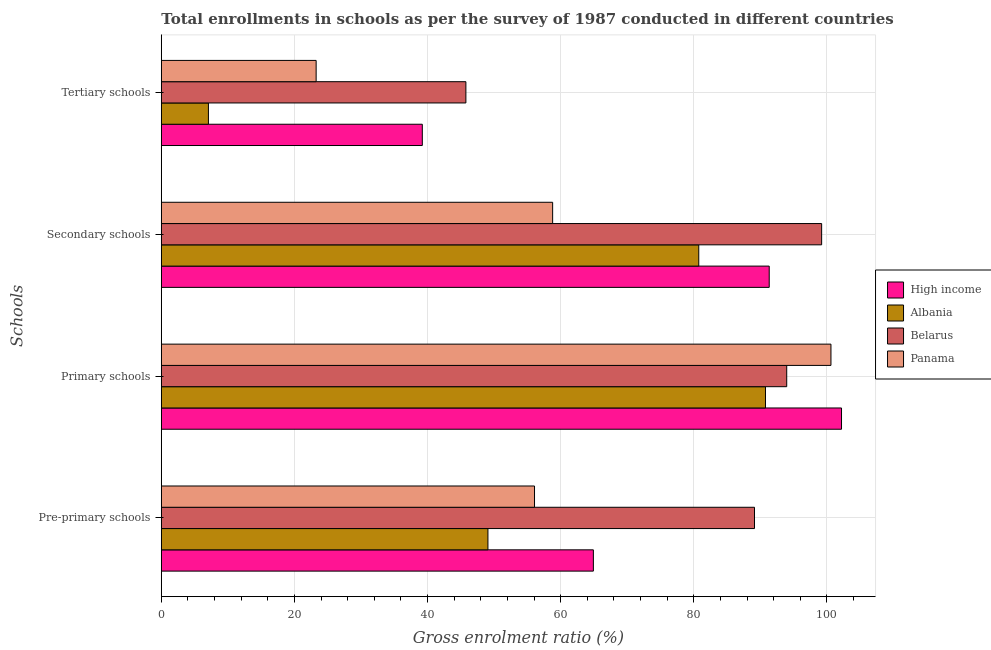How many groups of bars are there?
Offer a very short reply. 4. Are the number of bars per tick equal to the number of legend labels?
Provide a succinct answer. Yes. Are the number of bars on each tick of the Y-axis equal?
Your answer should be very brief. Yes. How many bars are there on the 1st tick from the top?
Offer a very short reply. 4. What is the label of the 1st group of bars from the top?
Keep it short and to the point. Tertiary schools. What is the gross enrolment ratio in pre-primary schools in Belarus?
Provide a succinct answer. 89.12. Across all countries, what is the maximum gross enrolment ratio in primary schools?
Offer a very short reply. 102.19. Across all countries, what is the minimum gross enrolment ratio in pre-primary schools?
Your response must be concise. 49.07. In which country was the gross enrolment ratio in pre-primary schools maximum?
Offer a very short reply. Belarus. In which country was the gross enrolment ratio in pre-primary schools minimum?
Provide a succinct answer. Albania. What is the total gross enrolment ratio in primary schools in the graph?
Provide a short and direct response. 387.51. What is the difference between the gross enrolment ratio in tertiary schools in Belarus and that in Albania?
Provide a short and direct response. 38.68. What is the difference between the gross enrolment ratio in tertiary schools in High income and the gross enrolment ratio in pre-primary schools in Belarus?
Your answer should be compact. -49.91. What is the average gross enrolment ratio in primary schools per country?
Offer a very short reply. 96.88. What is the difference between the gross enrolment ratio in tertiary schools and gross enrolment ratio in secondary schools in Albania?
Provide a succinct answer. -73.67. What is the ratio of the gross enrolment ratio in secondary schools in Panama to that in Belarus?
Your answer should be very brief. 0.59. What is the difference between the highest and the second highest gross enrolment ratio in secondary schools?
Make the answer very short. 7.88. What is the difference between the highest and the lowest gross enrolment ratio in secondary schools?
Offer a very short reply. 40.41. In how many countries, is the gross enrolment ratio in primary schools greater than the average gross enrolment ratio in primary schools taken over all countries?
Offer a terse response. 2. What does the 2nd bar from the top in Tertiary schools represents?
Offer a terse response. Belarus. What does the 4th bar from the bottom in Pre-primary schools represents?
Your response must be concise. Panama. Is it the case that in every country, the sum of the gross enrolment ratio in pre-primary schools and gross enrolment ratio in primary schools is greater than the gross enrolment ratio in secondary schools?
Make the answer very short. Yes. Are all the bars in the graph horizontal?
Your response must be concise. Yes. How many countries are there in the graph?
Your answer should be compact. 4. Are the values on the major ticks of X-axis written in scientific E-notation?
Give a very brief answer. No. Where does the legend appear in the graph?
Give a very brief answer. Center right. How many legend labels are there?
Provide a succinct answer. 4. How are the legend labels stacked?
Give a very brief answer. Vertical. What is the title of the graph?
Offer a terse response. Total enrollments in schools as per the survey of 1987 conducted in different countries. Does "Malaysia" appear as one of the legend labels in the graph?
Your answer should be compact. No. What is the label or title of the Y-axis?
Keep it short and to the point. Schools. What is the Gross enrolment ratio (%) of High income in Pre-primary schools?
Provide a succinct answer. 64.91. What is the Gross enrolment ratio (%) of Albania in Pre-primary schools?
Your answer should be compact. 49.07. What is the Gross enrolment ratio (%) in Belarus in Pre-primary schools?
Ensure brevity in your answer.  89.12. What is the Gross enrolment ratio (%) of Panama in Pre-primary schools?
Your response must be concise. 56.07. What is the Gross enrolment ratio (%) in High income in Primary schools?
Make the answer very short. 102.19. What is the Gross enrolment ratio (%) in Albania in Primary schools?
Give a very brief answer. 90.77. What is the Gross enrolment ratio (%) in Belarus in Primary schools?
Offer a terse response. 93.95. What is the Gross enrolment ratio (%) in Panama in Primary schools?
Make the answer very short. 100.6. What is the Gross enrolment ratio (%) in High income in Secondary schools?
Offer a very short reply. 91.33. What is the Gross enrolment ratio (%) in Albania in Secondary schools?
Provide a succinct answer. 80.74. What is the Gross enrolment ratio (%) of Belarus in Secondary schools?
Ensure brevity in your answer.  99.2. What is the Gross enrolment ratio (%) in Panama in Secondary schools?
Provide a succinct answer. 58.79. What is the Gross enrolment ratio (%) of High income in Tertiary schools?
Offer a very short reply. 39.21. What is the Gross enrolment ratio (%) of Albania in Tertiary schools?
Provide a short and direct response. 7.08. What is the Gross enrolment ratio (%) in Belarus in Tertiary schools?
Your answer should be very brief. 45.76. What is the Gross enrolment ratio (%) in Panama in Tertiary schools?
Make the answer very short. 23.26. Across all Schools, what is the maximum Gross enrolment ratio (%) of High income?
Your response must be concise. 102.19. Across all Schools, what is the maximum Gross enrolment ratio (%) of Albania?
Ensure brevity in your answer.  90.77. Across all Schools, what is the maximum Gross enrolment ratio (%) in Belarus?
Offer a terse response. 99.2. Across all Schools, what is the maximum Gross enrolment ratio (%) in Panama?
Provide a succinct answer. 100.6. Across all Schools, what is the minimum Gross enrolment ratio (%) in High income?
Offer a very short reply. 39.21. Across all Schools, what is the minimum Gross enrolment ratio (%) of Albania?
Offer a very short reply. 7.08. Across all Schools, what is the minimum Gross enrolment ratio (%) of Belarus?
Provide a short and direct response. 45.76. Across all Schools, what is the minimum Gross enrolment ratio (%) of Panama?
Ensure brevity in your answer.  23.26. What is the total Gross enrolment ratio (%) in High income in the graph?
Your answer should be very brief. 297.63. What is the total Gross enrolment ratio (%) in Albania in the graph?
Your answer should be very brief. 227.65. What is the total Gross enrolment ratio (%) in Belarus in the graph?
Your response must be concise. 328.03. What is the total Gross enrolment ratio (%) of Panama in the graph?
Provide a short and direct response. 238.72. What is the difference between the Gross enrolment ratio (%) in High income in Pre-primary schools and that in Primary schools?
Provide a succinct answer. -37.28. What is the difference between the Gross enrolment ratio (%) in Albania in Pre-primary schools and that in Primary schools?
Your response must be concise. -41.7. What is the difference between the Gross enrolment ratio (%) of Belarus in Pre-primary schools and that in Primary schools?
Keep it short and to the point. -4.84. What is the difference between the Gross enrolment ratio (%) of Panama in Pre-primary schools and that in Primary schools?
Provide a short and direct response. -44.54. What is the difference between the Gross enrolment ratio (%) in High income in Pre-primary schools and that in Secondary schools?
Ensure brevity in your answer.  -26.42. What is the difference between the Gross enrolment ratio (%) in Albania in Pre-primary schools and that in Secondary schools?
Make the answer very short. -31.67. What is the difference between the Gross enrolment ratio (%) of Belarus in Pre-primary schools and that in Secondary schools?
Offer a very short reply. -10.09. What is the difference between the Gross enrolment ratio (%) of Panama in Pre-primary schools and that in Secondary schools?
Your answer should be very brief. -2.72. What is the difference between the Gross enrolment ratio (%) of High income in Pre-primary schools and that in Tertiary schools?
Your response must be concise. 25.7. What is the difference between the Gross enrolment ratio (%) in Albania in Pre-primary schools and that in Tertiary schools?
Your response must be concise. 41.99. What is the difference between the Gross enrolment ratio (%) of Belarus in Pre-primary schools and that in Tertiary schools?
Keep it short and to the point. 43.36. What is the difference between the Gross enrolment ratio (%) in Panama in Pre-primary schools and that in Tertiary schools?
Make the answer very short. 32.81. What is the difference between the Gross enrolment ratio (%) of High income in Primary schools and that in Secondary schools?
Keep it short and to the point. 10.86. What is the difference between the Gross enrolment ratio (%) of Albania in Primary schools and that in Secondary schools?
Provide a short and direct response. 10.02. What is the difference between the Gross enrolment ratio (%) in Belarus in Primary schools and that in Secondary schools?
Your response must be concise. -5.25. What is the difference between the Gross enrolment ratio (%) of Panama in Primary schools and that in Secondary schools?
Your answer should be compact. 41.81. What is the difference between the Gross enrolment ratio (%) in High income in Primary schools and that in Tertiary schools?
Offer a terse response. 62.98. What is the difference between the Gross enrolment ratio (%) in Albania in Primary schools and that in Tertiary schools?
Ensure brevity in your answer.  83.69. What is the difference between the Gross enrolment ratio (%) of Belarus in Primary schools and that in Tertiary schools?
Ensure brevity in your answer.  48.2. What is the difference between the Gross enrolment ratio (%) in Panama in Primary schools and that in Tertiary schools?
Your answer should be very brief. 77.34. What is the difference between the Gross enrolment ratio (%) in High income in Secondary schools and that in Tertiary schools?
Your response must be concise. 52.12. What is the difference between the Gross enrolment ratio (%) of Albania in Secondary schools and that in Tertiary schools?
Your answer should be very brief. 73.67. What is the difference between the Gross enrolment ratio (%) in Belarus in Secondary schools and that in Tertiary schools?
Offer a very short reply. 53.45. What is the difference between the Gross enrolment ratio (%) in Panama in Secondary schools and that in Tertiary schools?
Keep it short and to the point. 35.53. What is the difference between the Gross enrolment ratio (%) in High income in Pre-primary schools and the Gross enrolment ratio (%) in Albania in Primary schools?
Your answer should be very brief. -25.86. What is the difference between the Gross enrolment ratio (%) in High income in Pre-primary schools and the Gross enrolment ratio (%) in Belarus in Primary schools?
Your response must be concise. -29.04. What is the difference between the Gross enrolment ratio (%) of High income in Pre-primary schools and the Gross enrolment ratio (%) of Panama in Primary schools?
Your answer should be very brief. -35.69. What is the difference between the Gross enrolment ratio (%) of Albania in Pre-primary schools and the Gross enrolment ratio (%) of Belarus in Primary schools?
Ensure brevity in your answer.  -44.88. What is the difference between the Gross enrolment ratio (%) in Albania in Pre-primary schools and the Gross enrolment ratio (%) in Panama in Primary schools?
Provide a short and direct response. -51.53. What is the difference between the Gross enrolment ratio (%) of Belarus in Pre-primary schools and the Gross enrolment ratio (%) of Panama in Primary schools?
Your answer should be compact. -11.49. What is the difference between the Gross enrolment ratio (%) in High income in Pre-primary schools and the Gross enrolment ratio (%) in Albania in Secondary schools?
Your response must be concise. -15.83. What is the difference between the Gross enrolment ratio (%) of High income in Pre-primary schools and the Gross enrolment ratio (%) of Belarus in Secondary schools?
Keep it short and to the point. -34.29. What is the difference between the Gross enrolment ratio (%) of High income in Pre-primary schools and the Gross enrolment ratio (%) of Panama in Secondary schools?
Provide a succinct answer. 6.12. What is the difference between the Gross enrolment ratio (%) in Albania in Pre-primary schools and the Gross enrolment ratio (%) in Belarus in Secondary schools?
Your response must be concise. -50.13. What is the difference between the Gross enrolment ratio (%) in Albania in Pre-primary schools and the Gross enrolment ratio (%) in Panama in Secondary schools?
Offer a very short reply. -9.72. What is the difference between the Gross enrolment ratio (%) of Belarus in Pre-primary schools and the Gross enrolment ratio (%) of Panama in Secondary schools?
Your answer should be very brief. 30.33. What is the difference between the Gross enrolment ratio (%) of High income in Pre-primary schools and the Gross enrolment ratio (%) of Albania in Tertiary schools?
Make the answer very short. 57.83. What is the difference between the Gross enrolment ratio (%) of High income in Pre-primary schools and the Gross enrolment ratio (%) of Belarus in Tertiary schools?
Provide a short and direct response. 19.15. What is the difference between the Gross enrolment ratio (%) of High income in Pre-primary schools and the Gross enrolment ratio (%) of Panama in Tertiary schools?
Offer a very short reply. 41.65. What is the difference between the Gross enrolment ratio (%) of Albania in Pre-primary schools and the Gross enrolment ratio (%) of Belarus in Tertiary schools?
Offer a terse response. 3.31. What is the difference between the Gross enrolment ratio (%) of Albania in Pre-primary schools and the Gross enrolment ratio (%) of Panama in Tertiary schools?
Your answer should be compact. 25.81. What is the difference between the Gross enrolment ratio (%) in Belarus in Pre-primary schools and the Gross enrolment ratio (%) in Panama in Tertiary schools?
Offer a terse response. 65.85. What is the difference between the Gross enrolment ratio (%) in High income in Primary schools and the Gross enrolment ratio (%) in Albania in Secondary schools?
Offer a very short reply. 21.45. What is the difference between the Gross enrolment ratio (%) in High income in Primary schools and the Gross enrolment ratio (%) in Belarus in Secondary schools?
Your response must be concise. 2.98. What is the difference between the Gross enrolment ratio (%) in High income in Primary schools and the Gross enrolment ratio (%) in Panama in Secondary schools?
Offer a terse response. 43.4. What is the difference between the Gross enrolment ratio (%) in Albania in Primary schools and the Gross enrolment ratio (%) in Belarus in Secondary schools?
Make the answer very short. -8.44. What is the difference between the Gross enrolment ratio (%) of Albania in Primary schools and the Gross enrolment ratio (%) of Panama in Secondary schools?
Ensure brevity in your answer.  31.98. What is the difference between the Gross enrolment ratio (%) in Belarus in Primary schools and the Gross enrolment ratio (%) in Panama in Secondary schools?
Make the answer very short. 35.17. What is the difference between the Gross enrolment ratio (%) of High income in Primary schools and the Gross enrolment ratio (%) of Albania in Tertiary schools?
Your response must be concise. 95.11. What is the difference between the Gross enrolment ratio (%) of High income in Primary schools and the Gross enrolment ratio (%) of Belarus in Tertiary schools?
Your answer should be compact. 56.43. What is the difference between the Gross enrolment ratio (%) in High income in Primary schools and the Gross enrolment ratio (%) in Panama in Tertiary schools?
Your response must be concise. 78.93. What is the difference between the Gross enrolment ratio (%) of Albania in Primary schools and the Gross enrolment ratio (%) of Belarus in Tertiary schools?
Keep it short and to the point. 45.01. What is the difference between the Gross enrolment ratio (%) in Albania in Primary schools and the Gross enrolment ratio (%) in Panama in Tertiary schools?
Offer a terse response. 67.51. What is the difference between the Gross enrolment ratio (%) of Belarus in Primary schools and the Gross enrolment ratio (%) of Panama in Tertiary schools?
Make the answer very short. 70.69. What is the difference between the Gross enrolment ratio (%) in High income in Secondary schools and the Gross enrolment ratio (%) in Albania in Tertiary schools?
Provide a succinct answer. 84.25. What is the difference between the Gross enrolment ratio (%) of High income in Secondary schools and the Gross enrolment ratio (%) of Belarus in Tertiary schools?
Your answer should be compact. 45.57. What is the difference between the Gross enrolment ratio (%) of High income in Secondary schools and the Gross enrolment ratio (%) of Panama in Tertiary schools?
Give a very brief answer. 68.07. What is the difference between the Gross enrolment ratio (%) in Albania in Secondary schools and the Gross enrolment ratio (%) in Belarus in Tertiary schools?
Your answer should be compact. 34.99. What is the difference between the Gross enrolment ratio (%) of Albania in Secondary schools and the Gross enrolment ratio (%) of Panama in Tertiary schools?
Make the answer very short. 57.48. What is the difference between the Gross enrolment ratio (%) of Belarus in Secondary schools and the Gross enrolment ratio (%) of Panama in Tertiary schools?
Provide a succinct answer. 75.94. What is the average Gross enrolment ratio (%) of High income per Schools?
Provide a succinct answer. 74.41. What is the average Gross enrolment ratio (%) of Albania per Schools?
Your answer should be very brief. 56.91. What is the average Gross enrolment ratio (%) in Belarus per Schools?
Make the answer very short. 82.01. What is the average Gross enrolment ratio (%) in Panama per Schools?
Offer a terse response. 59.68. What is the difference between the Gross enrolment ratio (%) in High income and Gross enrolment ratio (%) in Albania in Pre-primary schools?
Provide a short and direct response. 15.84. What is the difference between the Gross enrolment ratio (%) of High income and Gross enrolment ratio (%) of Belarus in Pre-primary schools?
Offer a very short reply. -24.21. What is the difference between the Gross enrolment ratio (%) of High income and Gross enrolment ratio (%) of Panama in Pre-primary schools?
Provide a succinct answer. 8.84. What is the difference between the Gross enrolment ratio (%) of Albania and Gross enrolment ratio (%) of Belarus in Pre-primary schools?
Provide a short and direct response. -40.05. What is the difference between the Gross enrolment ratio (%) in Albania and Gross enrolment ratio (%) in Panama in Pre-primary schools?
Give a very brief answer. -7. What is the difference between the Gross enrolment ratio (%) in Belarus and Gross enrolment ratio (%) in Panama in Pre-primary schools?
Your answer should be very brief. 33.05. What is the difference between the Gross enrolment ratio (%) in High income and Gross enrolment ratio (%) in Albania in Primary schools?
Keep it short and to the point. 11.42. What is the difference between the Gross enrolment ratio (%) of High income and Gross enrolment ratio (%) of Belarus in Primary schools?
Provide a short and direct response. 8.23. What is the difference between the Gross enrolment ratio (%) in High income and Gross enrolment ratio (%) in Panama in Primary schools?
Your response must be concise. 1.59. What is the difference between the Gross enrolment ratio (%) in Albania and Gross enrolment ratio (%) in Belarus in Primary schools?
Make the answer very short. -3.19. What is the difference between the Gross enrolment ratio (%) in Albania and Gross enrolment ratio (%) in Panama in Primary schools?
Your answer should be compact. -9.84. What is the difference between the Gross enrolment ratio (%) of Belarus and Gross enrolment ratio (%) of Panama in Primary schools?
Offer a terse response. -6.65. What is the difference between the Gross enrolment ratio (%) of High income and Gross enrolment ratio (%) of Albania in Secondary schools?
Your response must be concise. 10.58. What is the difference between the Gross enrolment ratio (%) in High income and Gross enrolment ratio (%) in Belarus in Secondary schools?
Ensure brevity in your answer.  -7.88. What is the difference between the Gross enrolment ratio (%) of High income and Gross enrolment ratio (%) of Panama in Secondary schools?
Your answer should be compact. 32.54. What is the difference between the Gross enrolment ratio (%) in Albania and Gross enrolment ratio (%) in Belarus in Secondary schools?
Your answer should be very brief. -18.46. What is the difference between the Gross enrolment ratio (%) of Albania and Gross enrolment ratio (%) of Panama in Secondary schools?
Provide a short and direct response. 21.95. What is the difference between the Gross enrolment ratio (%) of Belarus and Gross enrolment ratio (%) of Panama in Secondary schools?
Offer a terse response. 40.41. What is the difference between the Gross enrolment ratio (%) in High income and Gross enrolment ratio (%) in Albania in Tertiary schools?
Your answer should be compact. 32.13. What is the difference between the Gross enrolment ratio (%) of High income and Gross enrolment ratio (%) of Belarus in Tertiary schools?
Your answer should be very brief. -6.55. What is the difference between the Gross enrolment ratio (%) in High income and Gross enrolment ratio (%) in Panama in Tertiary schools?
Your response must be concise. 15.95. What is the difference between the Gross enrolment ratio (%) of Albania and Gross enrolment ratio (%) of Belarus in Tertiary schools?
Your answer should be very brief. -38.68. What is the difference between the Gross enrolment ratio (%) in Albania and Gross enrolment ratio (%) in Panama in Tertiary schools?
Make the answer very short. -16.18. What is the difference between the Gross enrolment ratio (%) in Belarus and Gross enrolment ratio (%) in Panama in Tertiary schools?
Offer a very short reply. 22.5. What is the ratio of the Gross enrolment ratio (%) in High income in Pre-primary schools to that in Primary schools?
Give a very brief answer. 0.64. What is the ratio of the Gross enrolment ratio (%) in Albania in Pre-primary schools to that in Primary schools?
Offer a very short reply. 0.54. What is the ratio of the Gross enrolment ratio (%) in Belarus in Pre-primary schools to that in Primary schools?
Offer a terse response. 0.95. What is the ratio of the Gross enrolment ratio (%) in Panama in Pre-primary schools to that in Primary schools?
Make the answer very short. 0.56. What is the ratio of the Gross enrolment ratio (%) in High income in Pre-primary schools to that in Secondary schools?
Your response must be concise. 0.71. What is the ratio of the Gross enrolment ratio (%) in Albania in Pre-primary schools to that in Secondary schools?
Provide a short and direct response. 0.61. What is the ratio of the Gross enrolment ratio (%) in Belarus in Pre-primary schools to that in Secondary schools?
Give a very brief answer. 0.9. What is the ratio of the Gross enrolment ratio (%) of Panama in Pre-primary schools to that in Secondary schools?
Provide a short and direct response. 0.95. What is the ratio of the Gross enrolment ratio (%) of High income in Pre-primary schools to that in Tertiary schools?
Give a very brief answer. 1.66. What is the ratio of the Gross enrolment ratio (%) in Albania in Pre-primary schools to that in Tertiary schools?
Provide a short and direct response. 6.93. What is the ratio of the Gross enrolment ratio (%) in Belarus in Pre-primary schools to that in Tertiary schools?
Make the answer very short. 1.95. What is the ratio of the Gross enrolment ratio (%) of Panama in Pre-primary schools to that in Tertiary schools?
Give a very brief answer. 2.41. What is the ratio of the Gross enrolment ratio (%) in High income in Primary schools to that in Secondary schools?
Your answer should be compact. 1.12. What is the ratio of the Gross enrolment ratio (%) of Albania in Primary schools to that in Secondary schools?
Your answer should be compact. 1.12. What is the ratio of the Gross enrolment ratio (%) in Belarus in Primary schools to that in Secondary schools?
Provide a succinct answer. 0.95. What is the ratio of the Gross enrolment ratio (%) of Panama in Primary schools to that in Secondary schools?
Your answer should be compact. 1.71. What is the ratio of the Gross enrolment ratio (%) in High income in Primary schools to that in Tertiary schools?
Offer a terse response. 2.61. What is the ratio of the Gross enrolment ratio (%) of Albania in Primary schools to that in Tertiary schools?
Your response must be concise. 12.83. What is the ratio of the Gross enrolment ratio (%) of Belarus in Primary schools to that in Tertiary schools?
Your response must be concise. 2.05. What is the ratio of the Gross enrolment ratio (%) in Panama in Primary schools to that in Tertiary schools?
Your answer should be compact. 4.33. What is the ratio of the Gross enrolment ratio (%) in High income in Secondary schools to that in Tertiary schools?
Your response must be concise. 2.33. What is the ratio of the Gross enrolment ratio (%) of Albania in Secondary schools to that in Tertiary schools?
Give a very brief answer. 11.41. What is the ratio of the Gross enrolment ratio (%) of Belarus in Secondary schools to that in Tertiary schools?
Provide a short and direct response. 2.17. What is the ratio of the Gross enrolment ratio (%) of Panama in Secondary schools to that in Tertiary schools?
Offer a terse response. 2.53. What is the difference between the highest and the second highest Gross enrolment ratio (%) in High income?
Offer a very short reply. 10.86. What is the difference between the highest and the second highest Gross enrolment ratio (%) in Albania?
Your response must be concise. 10.02. What is the difference between the highest and the second highest Gross enrolment ratio (%) in Belarus?
Make the answer very short. 5.25. What is the difference between the highest and the second highest Gross enrolment ratio (%) in Panama?
Give a very brief answer. 41.81. What is the difference between the highest and the lowest Gross enrolment ratio (%) of High income?
Offer a terse response. 62.98. What is the difference between the highest and the lowest Gross enrolment ratio (%) in Albania?
Provide a succinct answer. 83.69. What is the difference between the highest and the lowest Gross enrolment ratio (%) of Belarus?
Your response must be concise. 53.45. What is the difference between the highest and the lowest Gross enrolment ratio (%) of Panama?
Make the answer very short. 77.34. 